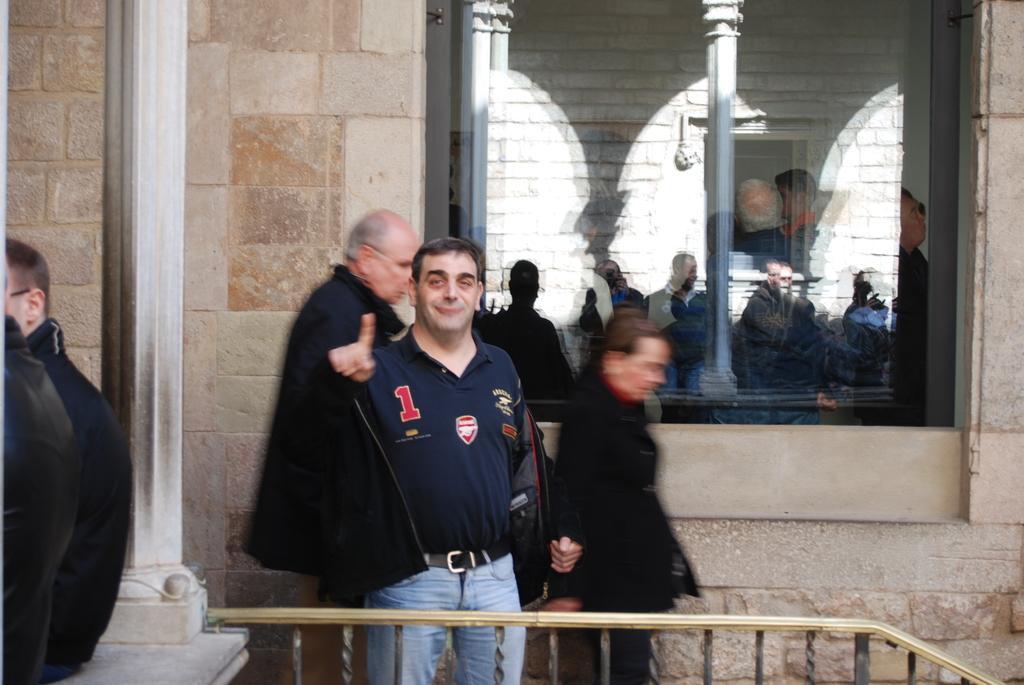Describe this image in one or two sentences. Here men are standing, this is wall and a window. 